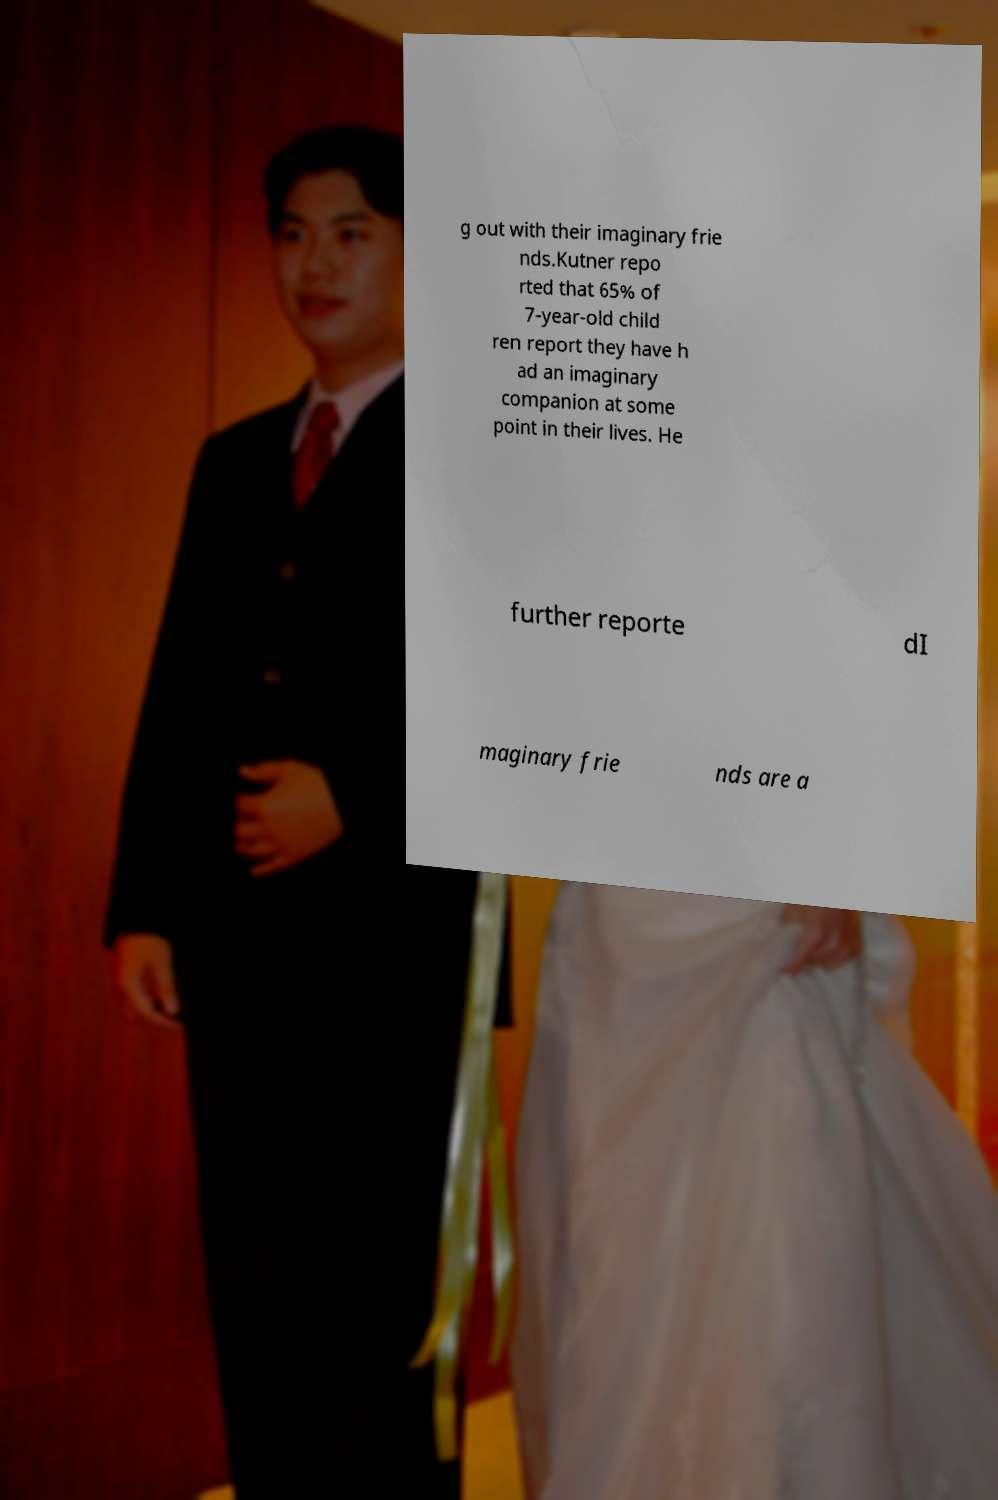Can you accurately transcribe the text from the provided image for me? g out with their imaginary frie nds.Kutner repo rted that 65% of 7-year-old child ren report they have h ad an imaginary companion at some point in their lives. He further reporte dI maginary frie nds are a 